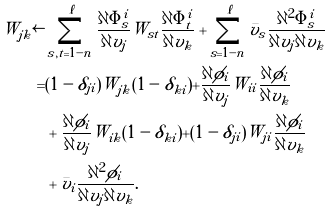<formula> <loc_0><loc_0><loc_500><loc_500>W _ { j k } \leftarrow & \sum _ { s , t = 1 - n } ^ { \ell } \frac { \partial \Phi ^ { i } _ { s } } { \partial v _ { j } } W _ { s t } \frac { \partial \Phi ^ { i } _ { t } } { \partial v _ { k } } + \sum _ { s = 1 - n } ^ { \ell } \bar { v } _ { s } \frac { \partial ^ { 2 } \Phi ^ { i } _ { s } } { \partial v _ { j } \partial v _ { k } } \\ = & ( 1 - \delta _ { j i } ) W _ { j k } ( 1 - \delta _ { k i } ) + \frac { \partial \phi _ { i } } { \partial v _ { j } } W _ { i i } \frac { \partial \phi _ { i } } { \partial v _ { k } } \\ & + \frac { \partial \phi _ { i } } { \partial v _ { j } } W _ { i k } ( 1 - \delta _ { k i } ) + ( 1 - \delta _ { j i } ) W _ { j i } \frac { \partial \phi _ { i } } { \partial v _ { k } } \\ & + \bar { v } _ { i } \frac { \partial ^ { 2 } \phi _ { i } } { \partial v _ { j } \partial v _ { k } } .</formula> 